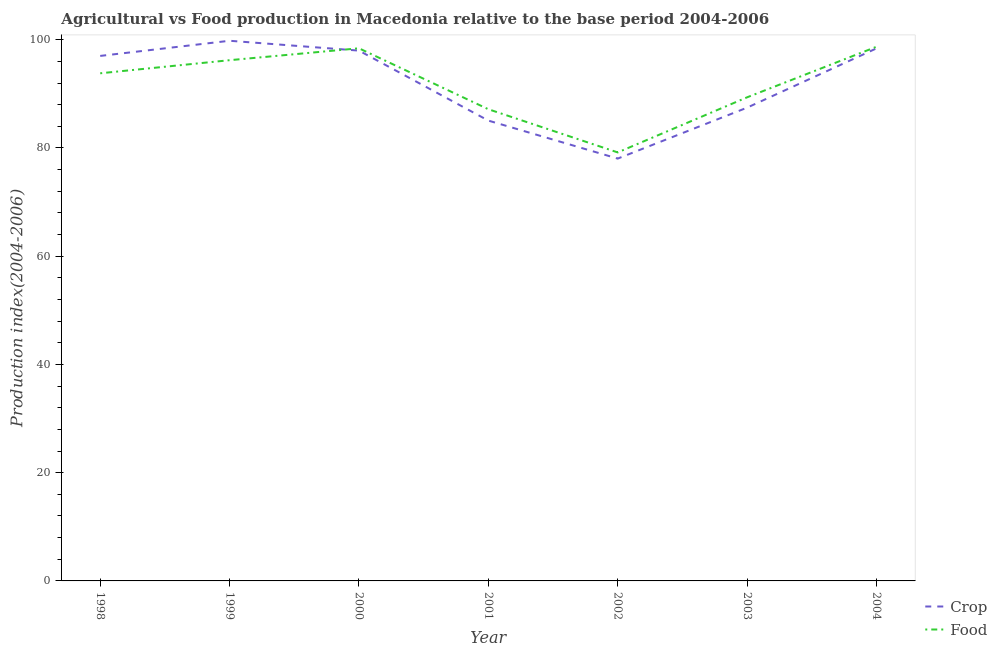How many different coloured lines are there?
Give a very brief answer. 2. What is the food production index in 2003?
Provide a short and direct response. 89.36. Across all years, what is the maximum crop production index?
Make the answer very short. 99.81. Across all years, what is the minimum food production index?
Provide a short and direct response. 79.18. In which year was the crop production index minimum?
Make the answer very short. 2002. What is the total crop production index in the graph?
Your response must be concise. 643.76. What is the difference between the food production index in 2001 and that in 2003?
Keep it short and to the point. -2.2. What is the difference between the food production index in 2000 and the crop production index in 1999?
Your response must be concise. -1.39. What is the average crop production index per year?
Offer a very short reply. 91.97. In the year 2002, what is the difference between the crop production index and food production index?
Keep it short and to the point. -1.14. In how many years, is the food production index greater than 8?
Ensure brevity in your answer.  7. What is the ratio of the crop production index in 1998 to that in 2003?
Your answer should be very brief. 1.11. Is the food production index in 1998 less than that in 2004?
Give a very brief answer. Yes. What is the difference between the highest and the second highest crop production index?
Keep it short and to the point. 1.41. What is the difference between the highest and the lowest crop production index?
Offer a very short reply. 21.77. Does the crop production index monotonically increase over the years?
Provide a short and direct response. No. Is the crop production index strictly greater than the food production index over the years?
Make the answer very short. No. How many lines are there?
Provide a short and direct response. 2. How many years are there in the graph?
Your answer should be very brief. 7. What is the difference between two consecutive major ticks on the Y-axis?
Offer a very short reply. 20. Are the values on the major ticks of Y-axis written in scientific E-notation?
Keep it short and to the point. No. Does the graph contain grids?
Your response must be concise. No. How many legend labels are there?
Offer a very short reply. 2. What is the title of the graph?
Your response must be concise. Agricultural vs Food production in Macedonia relative to the base period 2004-2006. What is the label or title of the X-axis?
Offer a terse response. Year. What is the label or title of the Y-axis?
Give a very brief answer. Production index(2004-2006). What is the Production index(2004-2006) in Crop in 1998?
Offer a very short reply. 97.01. What is the Production index(2004-2006) of Food in 1998?
Offer a terse response. 93.8. What is the Production index(2004-2006) of Crop in 1999?
Your answer should be compact. 99.81. What is the Production index(2004-2006) of Food in 1999?
Offer a very short reply. 96.22. What is the Production index(2004-2006) of Crop in 2000?
Offer a terse response. 97.99. What is the Production index(2004-2006) in Food in 2000?
Provide a succinct answer. 98.42. What is the Production index(2004-2006) of Crop in 2001?
Give a very brief answer. 85.06. What is the Production index(2004-2006) in Food in 2001?
Provide a short and direct response. 87.16. What is the Production index(2004-2006) of Crop in 2002?
Give a very brief answer. 78.04. What is the Production index(2004-2006) in Food in 2002?
Keep it short and to the point. 79.18. What is the Production index(2004-2006) of Crop in 2003?
Your response must be concise. 87.45. What is the Production index(2004-2006) in Food in 2003?
Ensure brevity in your answer.  89.36. What is the Production index(2004-2006) of Crop in 2004?
Offer a terse response. 98.4. What is the Production index(2004-2006) of Food in 2004?
Offer a very short reply. 98.7. Across all years, what is the maximum Production index(2004-2006) of Crop?
Provide a succinct answer. 99.81. Across all years, what is the maximum Production index(2004-2006) of Food?
Your answer should be very brief. 98.7. Across all years, what is the minimum Production index(2004-2006) of Crop?
Provide a succinct answer. 78.04. Across all years, what is the minimum Production index(2004-2006) of Food?
Provide a succinct answer. 79.18. What is the total Production index(2004-2006) in Crop in the graph?
Keep it short and to the point. 643.76. What is the total Production index(2004-2006) in Food in the graph?
Keep it short and to the point. 642.84. What is the difference between the Production index(2004-2006) in Crop in 1998 and that in 1999?
Your answer should be very brief. -2.8. What is the difference between the Production index(2004-2006) of Food in 1998 and that in 1999?
Your answer should be very brief. -2.42. What is the difference between the Production index(2004-2006) of Crop in 1998 and that in 2000?
Offer a terse response. -0.98. What is the difference between the Production index(2004-2006) in Food in 1998 and that in 2000?
Your response must be concise. -4.62. What is the difference between the Production index(2004-2006) of Crop in 1998 and that in 2001?
Offer a terse response. 11.95. What is the difference between the Production index(2004-2006) in Food in 1998 and that in 2001?
Provide a succinct answer. 6.64. What is the difference between the Production index(2004-2006) of Crop in 1998 and that in 2002?
Make the answer very short. 18.97. What is the difference between the Production index(2004-2006) of Food in 1998 and that in 2002?
Your answer should be very brief. 14.62. What is the difference between the Production index(2004-2006) of Crop in 1998 and that in 2003?
Offer a very short reply. 9.56. What is the difference between the Production index(2004-2006) of Food in 1998 and that in 2003?
Your answer should be very brief. 4.44. What is the difference between the Production index(2004-2006) of Crop in 1998 and that in 2004?
Make the answer very short. -1.39. What is the difference between the Production index(2004-2006) in Crop in 1999 and that in 2000?
Keep it short and to the point. 1.82. What is the difference between the Production index(2004-2006) in Crop in 1999 and that in 2001?
Give a very brief answer. 14.75. What is the difference between the Production index(2004-2006) of Food in 1999 and that in 2001?
Provide a succinct answer. 9.06. What is the difference between the Production index(2004-2006) in Crop in 1999 and that in 2002?
Your response must be concise. 21.77. What is the difference between the Production index(2004-2006) in Food in 1999 and that in 2002?
Ensure brevity in your answer.  17.04. What is the difference between the Production index(2004-2006) of Crop in 1999 and that in 2003?
Keep it short and to the point. 12.36. What is the difference between the Production index(2004-2006) in Food in 1999 and that in 2003?
Offer a very short reply. 6.86. What is the difference between the Production index(2004-2006) in Crop in 1999 and that in 2004?
Offer a very short reply. 1.41. What is the difference between the Production index(2004-2006) of Food in 1999 and that in 2004?
Provide a short and direct response. -2.48. What is the difference between the Production index(2004-2006) of Crop in 2000 and that in 2001?
Ensure brevity in your answer.  12.93. What is the difference between the Production index(2004-2006) in Food in 2000 and that in 2001?
Keep it short and to the point. 11.26. What is the difference between the Production index(2004-2006) in Crop in 2000 and that in 2002?
Give a very brief answer. 19.95. What is the difference between the Production index(2004-2006) in Food in 2000 and that in 2002?
Keep it short and to the point. 19.24. What is the difference between the Production index(2004-2006) of Crop in 2000 and that in 2003?
Give a very brief answer. 10.54. What is the difference between the Production index(2004-2006) of Food in 2000 and that in 2003?
Offer a very short reply. 9.06. What is the difference between the Production index(2004-2006) of Crop in 2000 and that in 2004?
Offer a terse response. -0.41. What is the difference between the Production index(2004-2006) in Food in 2000 and that in 2004?
Your response must be concise. -0.28. What is the difference between the Production index(2004-2006) in Crop in 2001 and that in 2002?
Ensure brevity in your answer.  7.02. What is the difference between the Production index(2004-2006) in Food in 2001 and that in 2002?
Offer a very short reply. 7.98. What is the difference between the Production index(2004-2006) in Crop in 2001 and that in 2003?
Provide a succinct answer. -2.39. What is the difference between the Production index(2004-2006) in Food in 2001 and that in 2003?
Provide a short and direct response. -2.2. What is the difference between the Production index(2004-2006) in Crop in 2001 and that in 2004?
Offer a terse response. -13.34. What is the difference between the Production index(2004-2006) in Food in 2001 and that in 2004?
Keep it short and to the point. -11.54. What is the difference between the Production index(2004-2006) of Crop in 2002 and that in 2003?
Ensure brevity in your answer.  -9.41. What is the difference between the Production index(2004-2006) of Food in 2002 and that in 2003?
Your answer should be compact. -10.18. What is the difference between the Production index(2004-2006) in Crop in 2002 and that in 2004?
Make the answer very short. -20.36. What is the difference between the Production index(2004-2006) of Food in 2002 and that in 2004?
Keep it short and to the point. -19.52. What is the difference between the Production index(2004-2006) of Crop in 2003 and that in 2004?
Give a very brief answer. -10.95. What is the difference between the Production index(2004-2006) in Food in 2003 and that in 2004?
Provide a short and direct response. -9.34. What is the difference between the Production index(2004-2006) in Crop in 1998 and the Production index(2004-2006) in Food in 1999?
Give a very brief answer. 0.79. What is the difference between the Production index(2004-2006) of Crop in 1998 and the Production index(2004-2006) of Food in 2000?
Offer a terse response. -1.41. What is the difference between the Production index(2004-2006) in Crop in 1998 and the Production index(2004-2006) in Food in 2001?
Give a very brief answer. 9.85. What is the difference between the Production index(2004-2006) in Crop in 1998 and the Production index(2004-2006) in Food in 2002?
Offer a terse response. 17.83. What is the difference between the Production index(2004-2006) of Crop in 1998 and the Production index(2004-2006) of Food in 2003?
Provide a succinct answer. 7.65. What is the difference between the Production index(2004-2006) in Crop in 1998 and the Production index(2004-2006) in Food in 2004?
Keep it short and to the point. -1.69. What is the difference between the Production index(2004-2006) of Crop in 1999 and the Production index(2004-2006) of Food in 2000?
Offer a very short reply. 1.39. What is the difference between the Production index(2004-2006) in Crop in 1999 and the Production index(2004-2006) in Food in 2001?
Provide a succinct answer. 12.65. What is the difference between the Production index(2004-2006) in Crop in 1999 and the Production index(2004-2006) in Food in 2002?
Your answer should be compact. 20.63. What is the difference between the Production index(2004-2006) in Crop in 1999 and the Production index(2004-2006) in Food in 2003?
Provide a succinct answer. 10.45. What is the difference between the Production index(2004-2006) in Crop in 1999 and the Production index(2004-2006) in Food in 2004?
Your answer should be very brief. 1.11. What is the difference between the Production index(2004-2006) in Crop in 2000 and the Production index(2004-2006) in Food in 2001?
Your response must be concise. 10.83. What is the difference between the Production index(2004-2006) of Crop in 2000 and the Production index(2004-2006) of Food in 2002?
Keep it short and to the point. 18.81. What is the difference between the Production index(2004-2006) of Crop in 2000 and the Production index(2004-2006) of Food in 2003?
Ensure brevity in your answer.  8.63. What is the difference between the Production index(2004-2006) of Crop in 2000 and the Production index(2004-2006) of Food in 2004?
Provide a succinct answer. -0.71. What is the difference between the Production index(2004-2006) in Crop in 2001 and the Production index(2004-2006) in Food in 2002?
Give a very brief answer. 5.88. What is the difference between the Production index(2004-2006) in Crop in 2001 and the Production index(2004-2006) in Food in 2003?
Your answer should be compact. -4.3. What is the difference between the Production index(2004-2006) in Crop in 2001 and the Production index(2004-2006) in Food in 2004?
Offer a very short reply. -13.64. What is the difference between the Production index(2004-2006) in Crop in 2002 and the Production index(2004-2006) in Food in 2003?
Your answer should be compact. -11.32. What is the difference between the Production index(2004-2006) of Crop in 2002 and the Production index(2004-2006) of Food in 2004?
Offer a terse response. -20.66. What is the difference between the Production index(2004-2006) in Crop in 2003 and the Production index(2004-2006) in Food in 2004?
Give a very brief answer. -11.25. What is the average Production index(2004-2006) in Crop per year?
Your response must be concise. 91.97. What is the average Production index(2004-2006) in Food per year?
Make the answer very short. 91.83. In the year 1998, what is the difference between the Production index(2004-2006) in Crop and Production index(2004-2006) in Food?
Your answer should be very brief. 3.21. In the year 1999, what is the difference between the Production index(2004-2006) in Crop and Production index(2004-2006) in Food?
Provide a short and direct response. 3.59. In the year 2000, what is the difference between the Production index(2004-2006) in Crop and Production index(2004-2006) in Food?
Offer a very short reply. -0.43. In the year 2002, what is the difference between the Production index(2004-2006) in Crop and Production index(2004-2006) in Food?
Provide a short and direct response. -1.14. In the year 2003, what is the difference between the Production index(2004-2006) of Crop and Production index(2004-2006) of Food?
Provide a short and direct response. -1.91. In the year 2004, what is the difference between the Production index(2004-2006) of Crop and Production index(2004-2006) of Food?
Your answer should be very brief. -0.3. What is the ratio of the Production index(2004-2006) of Crop in 1998 to that in 1999?
Ensure brevity in your answer.  0.97. What is the ratio of the Production index(2004-2006) of Food in 1998 to that in 1999?
Your answer should be compact. 0.97. What is the ratio of the Production index(2004-2006) of Food in 1998 to that in 2000?
Your response must be concise. 0.95. What is the ratio of the Production index(2004-2006) of Crop in 1998 to that in 2001?
Give a very brief answer. 1.14. What is the ratio of the Production index(2004-2006) of Food in 1998 to that in 2001?
Make the answer very short. 1.08. What is the ratio of the Production index(2004-2006) in Crop in 1998 to that in 2002?
Provide a succinct answer. 1.24. What is the ratio of the Production index(2004-2006) in Food in 1998 to that in 2002?
Offer a very short reply. 1.18. What is the ratio of the Production index(2004-2006) in Crop in 1998 to that in 2003?
Keep it short and to the point. 1.11. What is the ratio of the Production index(2004-2006) of Food in 1998 to that in 2003?
Your response must be concise. 1.05. What is the ratio of the Production index(2004-2006) in Crop in 1998 to that in 2004?
Ensure brevity in your answer.  0.99. What is the ratio of the Production index(2004-2006) in Food in 1998 to that in 2004?
Give a very brief answer. 0.95. What is the ratio of the Production index(2004-2006) in Crop in 1999 to that in 2000?
Provide a short and direct response. 1.02. What is the ratio of the Production index(2004-2006) of Food in 1999 to that in 2000?
Your answer should be compact. 0.98. What is the ratio of the Production index(2004-2006) in Crop in 1999 to that in 2001?
Your answer should be very brief. 1.17. What is the ratio of the Production index(2004-2006) of Food in 1999 to that in 2001?
Make the answer very short. 1.1. What is the ratio of the Production index(2004-2006) in Crop in 1999 to that in 2002?
Give a very brief answer. 1.28. What is the ratio of the Production index(2004-2006) of Food in 1999 to that in 2002?
Your answer should be compact. 1.22. What is the ratio of the Production index(2004-2006) of Crop in 1999 to that in 2003?
Offer a terse response. 1.14. What is the ratio of the Production index(2004-2006) in Food in 1999 to that in 2003?
Your response must be concise. 1.08. What is the ratio of the Production index(2004-2006) in Crop in 1999 to that in 2004?
Offer a terse response. 1.01. What is the ratio of the Production index(2004-2006) in Food in 1999 to that in 2004?
Give a very brief answer. 0.97. What is the ratio of the Production index(2004-2006) of Crop in 2000 to that in 2001?
Offer a terse response. 1.15. What is the ratio of the Production index(2004-2006) in Food in 2000 to that in 2001?
Your answer should be very brief. 1.13. What is the ratio of the Production index(2004-2006) in Crop in 2000 to that in 2002?
Ensure brevity in your answer.  1.26. What is the ratio of the Production index(2004-2006) in Food in 2000 to that in 2002?
Offer a very short reply. 1.24. What is the ratio of the Production index(2004-2006) in Crop in 2000 to that in 2003?
Offer a terse response. 1.12. What is the ratio of the Production index(2004-2006) of Food in 2000 to that in 2003?
Provide a succinct answer. 1.1. What is the ratio of the Production index(2004-2006) of Crop in 2001 to that in 2002?
Your response must be concise. 1.09. What is the ratio of the Production index(2004-2006) of Food in 2001 to that in 2002?
Your response must be concise. 1.1. What is the ratio of the Production index(2004-2006) of Crop in 2001 to that in 2003?
Your response must be concise. 0.97. What is the ratio of the Production index(2004-2006) of Food in 2001 to that in 2003?
Provide a succinct answer. 0.98. What is the ratio of the Production index(2004-2006) of Crop in 2001 to that in 2004?
Offer a very short reply. 0.86. What is the ratio of the Production index(2004-2006) in Food in 2001 to that in 2004?
Make the answer very short. 0.88. What is the ratio of the Production index(2004-2006) in Crop in 2002 to that in 2003?
Provide a short and direct response. 0.89. What is the ratio of the Production index(2004-2006) of Food in 2002 to that in 2003?
Ensure brevity in your answer.  0.89. What is the ratio of the Production index(2004-2006) in Crop in 2002 to that in 2004?
Offer a very short reply. 0.79. What is the ratio of the Production index(2004-2006) in Food in 2002 to that in 2004?
Provide a short and direct response. 0.8. What is the ratio of the Production index(2004-2006) of Crop in 2003 to that in 2004?
Make the answer very short. 0.89. What is the ratio of the Production index(2004-2006) in Food in 2003 to that in 2004?
Provide a short and direct response. 0.91. What is the difference between the highest and the second highest Production index(2004-2006) of Crop?
Offer a very short reply. 1.41. What is the difference between the highest and the second highest Production index(2004-2006) of Food?
Give a very brief answer. 0.28. What is the difference between the highest and the lowest Production index(2004-2006) of Crop?
Provide a short and direct response. 21.77. What is the difference between the highest and the lowest Production index(2004-2006) in Food?
Make the answer very short. 19.52. 